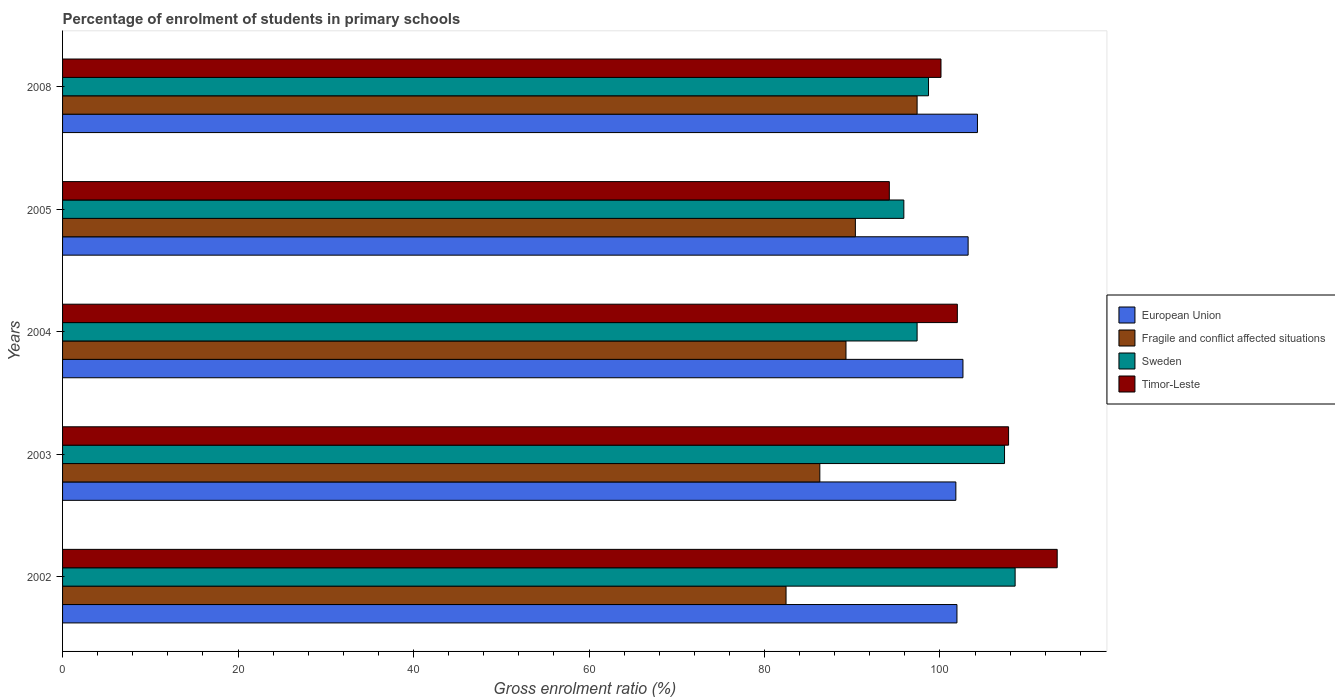How many different coloured bars are there?
Ensure brevity in your answer.  4. Are the number of bars per tick equal to the number of legend labels?
Give a very brief answer. Yes. Are the number of bars on each tick of the Y-axis equal?
Provide a short and direct response. Yes. How many bars are there on the 3rd tick from the top?
Make the answer very short. 4. How many bars are there on the 5th tick from the bottom?
Keep it short and to the point. 4. What is the label of the 2nd group of bars from the top?
Keep it short and to the point. 2005. In how many cases, is the number of bars for a given year not equal to the number of legend labels?
Your response must be concise. 0. What is the percentage of students enrolled in primary schools in Timor-Leste in 2003?
Your answer should be very brief. 107.82. Across all years, what is the maximum percentage of students enrolled in primary schools in European Union?
Provide a succinct answer. 104.27. Across all years, what is the minimum percentage of students enrolled in primary schools in Sweden?
Keep it short and to the point. 95.88. In which year was the percentage of students enrolled in primary schools in Timor-Leste maximum?
Keep it short and to the point. 2002. What is the total percentage of students enrolled in primary schools in Sweden in the graph?
Your answer should be compact. 507.89. What is the difference between the percentage of students enrolled in primary schools in European Union in 2005 and that in 2008?
Your response must be concise. -1.06. What is the difference between the percentage of students enrolled in primary schools in European Union in 2008 and the percentage of students enrolled in primary schools in Fragile and conflict affected situations in 2003?
Your answer should be very brief. 17.97. What is the average percentage of students enrolled in primary schools in Sweden per year?
Your answer should be very brief. 101.58. In the year 2002, what is the difference between the percentage of students enrolled in primary schools in Timor-Leste and percentage of students enrolled in primary schools in European Union?
Your answer should be very brief. 11.43. What is the ratio of the percentage of students enrolled in primary schools in Timor-Leste in 2003 to that in 2005?
Keep it short and to the point. 1.14. Is the percentage of students enrolled in primary schools in Sweden in 2005 less than that in 2008?
Provide a short and direct response. Yes. Is the difference between the percentage of students enrolled in primary schools in Timor-Leste in 2003 and 2004 greater than the difference between the percentage of students enrolled in primary schools in European Union in 2003 and 2004?
Offer a terse response. Yes. What is the difference between the highest and the second highest percentage of students enrolled in primary schools in Timor-Leste?
Offer a terse response. 5.54. What is the difference between the highest and the lowest percentage of students enrolled in primary schools in Timor-Leste?
Provide a succinct answer. 19.13. In how many years, is the percentage of students enrolled in primary schools in Timor-Leste greater than the average percentage of students enrolled in primary schools in Timor-Leste taken over all years?
Offer a terse response. 2. Is the sum of the percentage of students enrolled in primary schools in European Union in 2002 and 2008 greater than the maximum percentage of students enrolled in primary schools in Fragile and conflict affected situations across all years?
Provide a short and direct response. Yes. What does the 4th bar from the top in 2008 represents?
Keep it short and to the point. European Union. Is it the case that in every year, the sum of the percentage of students enrolled in primary schools in Timor-Leste and percentage of students enrolled in primary schools in Sweden is greater than the percentage of students enrolled in primary schools in European Union?
Give a very brief answer. Yes. How many years are there in the graph?
Ensure brevity in your answer.  5. Are the values on the major ticks of X-axis written in scientific E-notation?
Your response must be concise. No. Does the graph contain any zero values?
Offer a terse response. No. Does the graph contain grids?
Give a very brief answer. No. What is the title of the graph?
Provide a short and direct response. Percentage of enrolment of students in primary schools. Does "Turkey" appear as one of the legend labels in the graph?
Your response must be concise. No. What is the label or title of the X-axis?
Your answer should be compact. Gross enrolment ratio (%). What is the label or title of the Y-axis?
Give a very brief answer. Years. What is the Gross enrolment ratio (%) of European Union in 2002?
Your response must be concise. 101.93. What is the Gross enrolment ratio (%) in Fragile and conflict affected situations in 2002?
Provide a short and direct response. 82.46. What is the Gross enrolment ratio (%) of Sweden in 2002?
Offer a very short reply. 108.56. What is the Gross enrolment ratio (%) of Timor-Leste in 2002?
Ensure brevity in your answer.  113.36. What is the Gross enrolment ratio (%) of European Union in 2003?
Provide a succinct answer. 101.81. What is the Gross enrolment ratio (%) in Fragile and conflict affected situations in 2003?
Your response must be concise. 86.31. What is the Gross enrolment ratio (%) in Sweden in 2003?
Make the answer very short. 107.36. What is the Gross enrolment ratio (%) of Timor-Leste in 2003?
Provide a succinct answer. 107.82. What is the Gross enrolment ratio (%) in European Union in 2004?
Your answer should be very brief. 102.62. What is the Gross enrolment ratio (%) in Fragile and conflict affected situations in 2004?
Ensure brevity in your answer.  89.29. What is the Gross enrolment ratio (%) of Sweden in 2004?
Provide a short and direct response. 97.39. What is the Gross enrolment ratio (%) in Timor-Leste in 2004?
Your answer should be compact. 101.98. What is the Gross enrolment ratio (%) of European Union in 2005?
Your answer should be very brief. 103.21. What is the Gross enrolment ratio (%) in Fragile and conflict affected situations in 2005?
Offer a very short reply. 90.36. What is the Gross enrolment ratio (%) in Sweden in 2005?
Make the answer very short. 95.88. What is the Gross enrolment ratio (%) of Timor-Leste in 2005?
Provide a succinct answer. 94.23. What is the Gross enrolment ratio (%) in European Union in 2008?
Provide a succinct answer. 104.27. What is the Gross enrolment ratio (%) in Fragile and conflict affected situations in 2008?
Keep it short and to the point. 97.39. What is the Gross enrolment ratio (%) of Sweden in 2008?
Provide a succinct answer. 98.69. What is the Gross enrolment ratio (%) in Timor-Leste in 2008?
Provide a short and direct response. 100.11. Across all years, what is the maximum Gross enrolment ratio (%) in European Union?
Provide a succinct answer. 104.27. Across all years, what is the maximum Gross enrolment ratio (%) in Fragile and conflict affected situations?
Your answer should be very brief. 97.39. Across all years, what is the maximum Gross enrolment ratio (%) in Sweden?
Offer a terse response. 108.56. Across all years, what is the maximum Gross enrolment ratio (%) in Timor-Leste?
Keep it short and to the point. 113.36. Across all years, what is the minimum Gross enrolment ratio (%) in European Union?
Offer a terse response. 101.81. Across all years, what is the minimum Gross enrolment ratio (%) in Fragile and conflict affected situations?
Offer a terse response. 82.46. Across all years, what is the minimum Gross enrolment ratio (%) in Sweden?
Your answer should be very brief. 95.88. Across all years, what is the minimum Gross enrolment ratio (%) in Timor-Leste?
Provide a short and direct response. 94.23. What is the total Gross enrolment ratio (%) in European Union in the graph?
Your answer should be very brief. 513.84. What is the total Gross enrolment ratio (%) in Fragile and conflict affected situations in the graph?
Offer a very short reply. 445.8. What is the total Gross enrolment ratio (%) of Sweden in the graph?
Ensure brevity in your answer.  507.89. What is the total Gross enrolment ratio (%) of Timor-Leste in the graph?
Offer a very short reply. 517.5. What is the difference between the Gross enrolment ratio (%) in European Union in 2002 and that in 2003?
Your answer should be very brief. 0.12. What is the difference between the Gross enrolment ratio (%) of Fragile and conflict affected situations in 2002 and that in 2003?
Provide a short and direct response. -3.85. What is the difference between the Gross enrolment ratio (%) in Sweden in 2002 and that in 2003?
Keep it short and to the point. 1.21. What is the difference between the Gross enrolment ratio (%) of Timor-Leste in 2002 and that in 2003?
Ensure brevity in your answer.  5.54. What is the difference between the Gross enrolment ratio (%) in European Union in 2002 and that in 2004?
Make the answer very short. -0.68. What is the difference between the Gross enrolment ratio (%) in Fragile and conflict affected situations in 2002 and that in 2004?
Your answer should be compact. -6.83. What is the difference between the Gross enrolment ratio (%) in Sweden in 2002 and that in 2004?
Your answer should be compact. 11.17. What is the difference between the Gross enrolment ratio (%) of Timor-Leste in 2002 and that in 2004?
Ensure brevity in your answer.  11.38. What is the difference between the Gross enrolment ratio (%) in European Union in 2002 and that in 2005?
Make the answer very short. -1.27. What is the difference between the Gross enrolment ratio (%) of Fragile and conflict affected situations in 2002 and that in 2005?
Your response must be concise. -7.9. What is the difference between the Gross enrolment ratio (%) in Sweden in 2002 and that in 2005?
Your answer should be very brief. 12.68. What is the difference between the Gross enrolment ratio (%) of Timor-Leste in 2002 and that in 2005?
Ensure brevity in your answer.  19.13. What is the difference between the Gross enrolment ratio (%) in European Union in 2002 and that in 2008?
Give a very brief answer. -2.34. What is the difference between the Gross enrolment ratio (%) of Fragile and conflict affected situations in 2002 and that in 2008?
Provide a short and direct response. -14.94. What is the difference between the Gross enrolment ratio (%) in Sweden in 2002 and that in 2008?
Provide a short and direct response. 9.87. What is the difference between the Gross enrolment ratio (%) of Timor-Leste in 2002 and that in 2008?
Give a very brief answer. 13.24. What is the difference between the Gross enrolment ratio (%) in European Union in 2003 and that in 2004?
Your response must be concise. -0.81. What is the difference between the Gross enrolment ratio (%) in Fragile and conflict affected situations in 2003 and that in 2004?
Your answer should be compact. -2.98. What is the difference between the Gross enrolment ratio (%) of Sweden in 2003 and that in 2004?
Offer a very short reply. 9.96. What is the difference between the Gross enrolment ratio (%) in Timor-Leste in 2003 and that in 2004?
Provide a succinct answer. 5.84. What is the difference between the Gross enrolment ratio (%) in European Union in 2003 and that in 2005?
Give a very brief answer. -1.4. What is the difference between the Gross enrolment ratio (%) of Fragile and conflict affected situations in 2003 and that in 2005?
Make the answer very short. -4.05. What is the difference between the Gross enrolment ratio (%) in Sweden in 2003 and that in 2005?
Your answer should be very brief. 11.47. What is the difference between the Gross enrolment ratio (%) of Timor-Leste in 2003 and that in 2005?
Ensure brevity in your answer.  13.59. What is the difference between the Gross enrolment ratio (%) in European Union in 2003 and that in 2008?
Make the answer very short. -2.46. What is the difference between the Gross enrolment ratio (%) of Fragile and conflict affected situations in 2003 and that in 2008?
Provide a short and direct response. -11.09. What is the difference between the Gross enrolment ratio (%) of Sweden in 2003 and that in 2008?
Make the answer very short. 8.66. What is the difference between the Gross enrolment ratio (%) in Timor-Leste in 2003 and that in 2008?
Ensure brevity in your answer.  7.7. What is the difference between the Gross enrolment ratio (%) of European Union in 2004 and that in 2005?
Your answer should be compact. -0.59. What is the difference between the Gross enrolment ratio (%) of Fragile and conflict affected situations in 2004 and that in 2005?
Your answer should be very brief. -1.07. What is the difference between the Gross enrolment ratio (%) of Sweden in 2004 and that in 2005?
Your response must be concise. 1.51. What is the difference between the Gross enrolment ratio (%) in Timor-Leste in 2004 and that in 2005?
Provide a succinct answer. 7.75. What is the difference between the Gross enrolment ratio (%) of European Union in 2004 and that in 2008?
Offer a terse response. -1.65. What is the difference between the Gross enrolment ratio (%) in Fragile and conflict affected situations in 2004 and that in 2008?
Your answer should be compact. -8.11. What is the difference between the Gross enrolment ratio (%) of Sweden in 2004 and that in 2008?
Give a very brief answer. -1.3. What is the difference between the Gross enrolment ratio (%) of Timor-Leste in 2004 and that in 2008?
Offer a very short reply. 1.86. What is the difference between the Gross enrolment ratio (%) in European Union in 2005 and that in 2008?
Give a very brief answer. -1.06. What is the difference between the Gross enrolment ratio (%) in Fragile and conflict affected situations in 2005 and that in 2008?
Keep it short and to the point. -7.04. What is the difference between the Gross enrolment ratio (%) in Sweden in 2005 and that in 2008?
Keep it short and to the point. -2.81. What is the difference between the Gross enrolment ratio (%) of Timor-Leste in 2005 and that in 2008?
Provide a succinct answer. -5.89. What is the difference between the Gross enrolment ratio (%) of European Union in 2002 and the Gross enrolment ratio (%) of Fragile and conflict affected situations in 2003?
Make the answer very short. 15.63. What is the difference between the Gross enrolment ratio (%) in European Union in 2002 and the Gross enrolment ratio (%) in Sweden in 2003?
Your answer should be very brief. -5.42. What is the difference between the Gross enrolment ratio (%) of European Union in 2002 and the Gross enrolment ratio (%) of Timor-Leste in 2003?
Offer a terse response. -5.88. What is the difference between the Gross enrolment ratio (%) of Fragile and conflict affected situations in 2002 and the Gross enrolment ratio (%) of Sweden in 2003?
Provide a short and direct response. -24.9. What is the difference between the Gross enrolment ratio (%) of Fragile and conflict affected situations in 2002 and the Gross enrolment ratio (%) of Timor-Leste in 2003?
Your answer should be very brief. -25.36. What is the difference between the Gross enrolment ratio (%) of Sweden in 2002 and the Gross enrolment ratio (%) of Timor-Leste in 2003?
Make the answer very short. 0.75. What is the difference between the Gross enrolment ratio (%) in European Union in 2002 and the Gross enrolment ratio (%) in Fragile and conflict affected situations in 2004?
Provide a succinct answer. 12.65. What is the difference between the Gross enrolment ratio (%) in European Union in 2002 and the Gross enrolment ratio (%) in Sweden in 2004?
Give a very brief answer. 4.54. What is the difference between the Gross enrolment ratio (%) in European Union in 2002 and the Gross enrolment ratio (%) in Timor-Leste in 2004?
Provide a succinct answer. -0.05. What is the difference between the Gross enrolment ratio (%) in Fragile and conflict affected situations in 2002 and the Gross enrolment ratio (%) in Sweden in 2004?
Ensure brevity in your answer.  -14.94. What is the difference between the Gross enrolment ratio (%) of Fragile and conflict affected situations in 2002 and the Gross enrolment ratio (%) of Timor-Leste in 2004?
Your response must be concise. -19.52. What is the difference between the Gross enrolment ratio (%) in Sweden in 2002 and the Gross enrolment ratio (%) in Timor-Leste in 2004?
Provide a succinct answer. 6.59. What is the difference between the Gross enrolment ratio (%) in European Union in 2002 and the Gross enrolment ratio (%) in Fragile and conflict affected situations in 2005?
Your response must be concise. 11.58. What is the difference between the Gross enrolment ratio (%) in European Union in 2002 and the Gross enrolment ratio (%) in Sweden in 2005?
Offer a very short reply. 6.05. What is the difference between the Gross enrolment ratio (%) in European Union in 2002 and the Gross enrolment ratio (%) in Timor-Leste in 2005?
Give a very brief answer. 7.71. What is the difference between the Gross enrolment ratio (%) of Fragile and conflict affected situations in 2002 and the Gross enrolment ratio (%) of Sweden in 2005?
Make the answer very short. -13.43. What is the difference between the Gross enrolment ratio (%) in Fragile and conflict affected situations in 2002 and the Gross enrolment ratio (%) in Timor-Leste in 2005?
Give a very brief answer. -11.77. What is the difference between the Gross enrolment ratio (%) in Sweden in 2002 and the Gross enrolment ratio (%) in Timor-Leste in 2005?
Keep it short and to the point. 14.34. What is the difference between the Gross enrolment ratio (%) in European Union in 2002 and the Gross enrolment ratio (%) in Fragile and conflict affected situations in 2008?
Make the answer very short. 4.54. What is the difference between the Gross enrolment ratio (%) of European Union in 2002 and the Gross enrolment ratio (%) of Sweden in 2008?
Offer a very short reply. 3.24. What is the difference between the Gross enrolment ratio (%) of European Union in 2002 and the Gross enrolment ratio (%) of Timor-Leste in 2008?
Keep it short and to the point. 1.82. What is the difference between the Gross enrolment ratio (%) of Fragile and conflict affected situations in 2002 and the Gross enrolment ratio (%) of Sweden in 2008?
Provide a short and direct response. -16.24. What is the difference between the Gross enrolment ratio (%) in Fragile and conflict affected situations in 2002 and the Gross enrolment ratio (%) in Timor-Leste in 2008?
Your response must be concise. -17.66. What is the difference between the Gross enrolment ratio (%) of Sweden in 2002 and the Gross enrolment ratio (%) of Timor-Leste in 2008?
Ensure brevity in your answer.  8.45. What is the difference between the Gross enrolment ratio (%) in European Union in 2003 and the Gross enrolment ratio (%) in Fragile and conflict affected situations in 2004?
Your answer should be very brief. 12.52. What is the difference between the Gross enrolment ratio (%) of European Union in 2003 and the Gross enrolment ratio (%) of Sweden in 2004?
Keep it short and to the point. 4.42. What is the difference between the Gross enrolment ratio (%) in European Union in 2003 and the Gross enrolment ratio (%) in Timor-Leste in 2004?
Provide a succinct answer. -0.17. What is the difference between the Gross enrolment ratio (%) in Fragile and conflict affected situations in 2003 and the Gross enrolment ratio (%) in Sweden in 2004?
Offer a very short reply. -11.09. What is the difference between the Gross enrolment ratio (%) in Fragile and conflict affected situations in 2003 and the Gross enrolment ratio (%) in Timor-Leste in 2004?
Offer a terse response. -15.67. What is the difference between the Gross enrolment ratio (%) in Sweden in 2003 and the Gross enrolment ratio (%) in Timor-Leste in 2004?
Your answer should be very brief. 5.38. What is the difference between the Gross enrolment ratio (%) in European Union in 2003 and the Gross enrolment ratio (%) in Fragile and conflict affected situations in 2005?
Offer a very short reply. 11.45. What is the difference between the Gross enrolment ratio (%) in European Union in 2003 and the Gross enrolment ratio (%) in Sweden in 2005?
Make the answer very short. 5.93. What is the difference between the Gross enrolment ratio (%) of European Union in 2003 and the Gross enrolment ratio (%) of Timor-Leste in 2005?
Offer a terse response. 7.58. What is the difference between the Gross enrolment ratio (%) of Fragile and conflict affected situations in 2003 and the Gross enrolment ratio (%) of Sweden in 2005?
Give a very brief answer. -9.58. What is the difference between the Gross enrolment ratio (%) of Fragile and conflict affected situations in 2003 and the Gross enrolment ratio (%) of Timor-Leste in 2005?
Your response must be concise. -7.92. What is the difference between the Gross enrolment ratio (%) in Sweden in 2003 and the Gross enrolment ratio (%) in Timor-Leste in 2005?
Your answer should be compact. 13.13. What is the difference between the Gross enrolment ratio (%) of European Union in 2003 and the Gross enrolment ratio (%) of Fragile and conflict affected situations in 2008?
Offer a terse response. 4.42. What is the difference between the Gross enrolment ratio (%) of European Union in 2003 and the Gross enrolment ratio (%) of Sweden in 2008?
Your answer should be very brief. 3.12. What is the difference between the Gross enrolment ratio (%) in European Union in 2003 and the Gross enrolment ratio (%) in Timor-Leste in 2008?
Provide a succinct answer. 1.69. What is the difference between the Gross enrolment ratio (%) in Fragile and conflict affected situations in 2003 and the Gross enrolment ratio (%) in Sweden in 2008?
Keep it short and to the point. -12.39. What is the difference between the Gross enrolment ratio (%) of Fragile and conflict affected situations in 2003 and the Gross enrolment ratio (%) of Timor-Leste in 2008?
Keep it short and to the point. -13.81. What is the difference between the Gross enrolment ratio (%) of Sweden in 2003 and the Gross enrolment ratio (%) of Timor-Leste in 2008?
Offer a very short reply. 7.24. What is the difference between the Gross enrolment ratio (%) of European Union in 2004 and the Gross enrolment ratio (%) of Fragile and conflict affected situations in 2005?
Ensure brevity in your answer.  12.26. What is the difference between the Gross enrolment ratio (%) in European Union in 2004 and the Gross enrolment ratio (%) in Sweden in 2005?
Offer a terse response. 6.74. What is the difference between the Gross enrolment ratio (%) in European Union in 2004 and the Gross enrolment ratio (%) in Timor-Leste in 2005?
Give a very brief answer. 8.39. What is the difference between the Gross enrolment ratio (%) of Fragile and conflict affected situations in 2004 and the Gross enrolment ratio (%) of Sweden in 2005?
Offer a terse response. -6.59. What is the difference between the Gross enrolment ratio (%) of Fragile and conflict affected situations in 2004 and the Gross enrolment ratio (%) of Timor-Leste in 2005?
Make the answer very short. -4.94. What is the difference between the Gross enrolment ratio (%) of Sweden in 2004 and the Gross enrolment ratio (%) of Timor-Leste in 2005?
Your answer should be compact. 3.17. What is the difference between the Gross enrolment ratio (%) of European Union in 2004 and the Gross enrolment ratio (%) of Fragile and conflict affected situations in 2008?
Offer a very short reply. 5.22. What is the difference between the Gross enrolment ratio (%) in European Union in 2004 and the Gross enrolment ratio (%) in Sweden in 2008?
Give a very brief answer. 3.92. What is the difference between the Gross enrolment ratio (%) in European Union in 2004 and the Gross enrolment ratio (%) in Timor-Leste in 2008?
Offer a very short reply. 2.5. What is the difference between the Gross enrolment ratio (%) of Fragile and conflict affected situations in 2004 and the Gross enrolment ratio (%) of Sweden in 2008?
Offer a terse response. -9.41. What is the difference between the Gross enrolment ratio (%) in Fragile and conflict affected situations in 2004 and the Gross enrolment ratio (%) in Timor-Leste in 2008?
Make the answer very short. -10.83. What is the difference between the Gross enrolment ratio (%) of Sweden in 2004 and the Gross enrolment ratio (%) of Timor-Leste in 2008?
Your answer should be compact. -2.72. What is the difference between the Gross enrolment ratio (%) in European Union in 2005 and the Gross enrolment ratio (%) in Fragile and conflict affected situations in 2008?
Your response must be concise. 5.81. What is the difference between the Gross enrolment ratio (%) in European Union in 2005 and the Gross enrolment ratio (%) in Sweden in 2008?
Keep it short and to the point. 4.51. What is the difference between the Gross enrolment ratio (%) in European Union in 2005 and the Gross enrolment ratio (%) in Timor-Leste in 2008?
Give a very brief answer. 3.09. What is the difference between the Gross enrolment ratio (%) in Fragile and conflict affected situations in 2005 and the Gross enrolment ratio (%) in Sweden in 2008?
Make the answer very short. -8.34. What is the difference between the Gross enrolment ratio (%) of Fragile and conflict affected situations in 2005 and the Gross enrolment ratio (%) of Timor-Leste in 2008?
Ensure brevity in your answer.  -9.76. What is the difference between the Gross enrolment ratio (%) of Sweden in 2005 and the Gross enrolment ratio (%) of Timor-Leste in 2008?
Give a very brief answer. -4.23. What is the average Gross enrolment ratio (%) of European Union per year?
Offer a very short reply. 102.77. What is the average Gross enrolment ratio (%) in Fragile and conflict affected situations per year?
Your answer should be compact. 89.16. What is the average Gross enrolment ratio (%) of Sweden per year?
Give a very brief answer. 101.58. What is the average Gross enrolment ratio (%) of Timor-Leste per year?
Your response must be concise. 103.5. In the year 2002, what is the difference between the Gross enrolment ratio (%) of European Union and Gross enrolment ratio (%) of Fragile and conflict affected situations?
Provide a succinct answer. 19.48. In the year 2002, what is the difference between the Gross enrolment ratio (%) in European Union and Gross enrolment ratio (%) in Sweden?
Offer a very short reply. -6.63. In the year 2002, what is the difference between the Gross enrolment ratio (%) of European Union and Gross enrolment ratio (%) of Timor-Leste?
Your answer should be very brief. -11.43. In the year 2002, what is the difference between the Gross enrolment ratio (%) of Fragile and conflict affected situations and Gross enrolment ratio (%) of Sweden?
Offer a terse response. -26.11. In the year 2002, what is the difference between the Gross enrolment ratio (%) in Fragile and conflict affected situations and Gross enrolment ratio (%) in Timor-Leste?
Provide a succinct answer. -30.9. In the year 2002, what is the difference between the Gross enrolment ratio (%) in Sweden and Gross enrolment ratio (%) in Timor-Leste?
Provide a succinct answer. -4.79. In the year 2003, what is the difference between the Gross enrolment ratio (%) in European Union and Gross enrolment ratio (%) in Fragile and conflict affected situations?
Your answer should be compact. 15.5. In the year 2003, what is the difference between the Gross enrolment ratio (%) in European Union and Gross enrolment ratio (%) in Sweden?
Give a very brief answer. -5.55. In the year 2003, what is the difference between the Gross enrolment ratio (%) of European Union and Gross enrolment ratio (%) of Timor-Leste?
Keep it short and to the point. -6.01. In the year 2003, what is the difference between the Gross enrolment ratio (%) in Fragile and conflict affected situations and Gross enrolment ratio (%) in Sweden?
Provide a succinct answer. -21.05. In the year 2003, what is the difference between the Gross enrolment ratio (%) in Fragile and conflict affected situations and Gross enrolment ratio (%) in Timor-Leste?
Give a very brief answer. -21.51. In the year 2003, what is the difference between the Gross enrolment ratio (%) in Sweden and Gross enrolment ratio (%) in Timor-Leste?
Provide a succinct answer. -0.46. In the year 2004, what is the difference between the Gross enrolment ratio (%) of European Union and Gross enrolment ratio (%) of Fragile and conflict affected situations?
Your answer should be compact. 13.33. In the year 2004, what is the difference between the Gross enrolment ratio (%) of European Union and Gross enrolment ratio (%) of Sweden?
Make the answer very short. 5.23. In the year 2004, what is the difference between the Gross enrolment ratio (%) of European Union and Gross enrolment ratio (%) of Timor-Leste?
Make the answer very short. 0.64. In the year 2004, what is the difference between the Gross enrolment ratio (%) in Fragile and conflict affected situations and Gross enrolment ratio (%) in Sweden?
Offer a very short reply. -8.11. In the year 2004, what is the difference between the Gross enrolment ratio (%) of Fragile and conflict affected situations and Gross enrolment ratio (%) of Timor-Leste?
Provide a short and direct response. -12.69. In the year 2004, what is the difference between the Gross enrolment ratio (%) of Sweden and Gross enrolment ratio (%) of Timor-Leste?
Offer a very short reply. -4.59. In the year 2005, what is the difference between the Gross enrolment ratio (%) in European Union and Gross enrolment ratio (%) in Fragile and conflict affected situations?
Your response must be concise. 12.85. In the year 2005, what is the difference between the Gross enrolment ratio (%) in European Union and Gross enrolment ratio (%) in Sweden?
Keep it short and to the point. 7.33. In the year 2005, what is the difference between the Gross enrolment ratio (%) in European Union and Gross enrolment ratio (%) in Timor-Leste?
Provide a succinct answer. 8.98. In the year 2005, what is the difference between the Gross enrolment ratio (%) in Fragile and conflict affected situations and Gross enrolment ratio (%) in Sweden?
Ensure brevity in your answer.  -5.52. In the year 2005, what is the difference between the Gross enrolment ratio (%) of Fragile and conflict affected situations and Gross enrolment ratio (%) of Timor-Leste?
Provide a short and direct response. -3.87. In the year 2005, what is the difference between the Gross enrolment ratio (%) of Sweden and Gross enrolment ratio (%) of Timor-Leste?
Your answer should be very brief. 1.66. In the year 2008, what is the difference between the Gross enrolment ratio (%) of European Union and Gross enrolment ratio (%) of Fragile and conflict affected situations?
Provide a succinct answer. 6.88. In the year 2008, what is the difference between the Gross enrolment ratio (%) in European Union and Gross enrolment ratio (%) in Sweden?
Provide a short and direct response. 5.58. In the year 2008, what is the difference between the Gross enrolment ratio (%) in European Union and Gross enrolment ratio (%) in Timor-Leste?
Keep it short and to the point. 4.16. In the year 2008, what is the difference between the Gross enrolment ratio (%) in Fragile and conflict affected situations and Gross enrolment ratio (%) in Sweden?
Make the answer very short. -1.3. In the year 2008, what is the difference between the Gross enrolment ratio (%) in Fragile and conflict affected situations and Gross enrolment ratio (%) in Timor-Leste?
Offer a very short reply. -2.72. In the year 2008, what is the difference between the Gross enrolment ratio (%) of Sweden and Gross enrolment ratio (%) of Timor-Leste?
Offer a very short reply. -1.42. What is the ratio of the Gross enrolment ratio (%) of European Union in 2002 to that in 2003?
Your answer should be very brief. 1. What is the ratio of the Gross enrolment ratio (%) of Fragile and conflict affected situations in 2002 to that in 2003?
Provide a succinct answer. 0.96. What is the ratio of the Gross enrolment ratio (%) of Sweden in 2002 to that in 2003?
Your answer should be very brief. 1.01. What is the ratio of the Gross enrolment ratio (%) in Timor-Leste in 2002 to that in 2003?
Make the answer very short. 1.05. What is the ratio of the Gross enrolment ratio (%) in European Union in 2002 to that in 2004?
Your response must be concise. 0.99. What is the ratio of the Gross enrolment ratio (%) in Fragile and conflict affected situations in 2002 to that in 2004?
Offer a terse response. 0.92. What is the ratio of the Gross enrolment ratio (%) of Sweden in 2002 to that in 2004?
Provide a succinct answer. 1.11. What is the ratio of the Gross enrolment ratio (%) of Timor-Leste in 2002 to that in 2004?
Provide a short and direct response. 1.11. What is the ratio of the Gross enrolment ratio (%) of European Union in 2002 to that in 2005?
Offer a very short reply. 0.99. What is the ratio of the Gross enrolment ratio (%) of Fragile and conflict affected situations in 2002 to that in 2005?
Ensure brevity in your answer.  0.91. What is the ratio of the Gross enrolment ratio (%) of Sweden in 2002 to that in 2005?
Ensure brevity in your answer.  1.13. What is the ratio of the Gross enrolment ratio (%) in Timor-Leste in 2002 to that in 2005?
Make the answer very short. 1.2. What is the ratio of the Gross enrolment ratio (%) in European Union in 2002 to that in 2008?
Offer a terse response. 0.98. What is the ratio of the Gross enrolment ratio (%) of Fragile and conflict affected situations in 2002 to that in 2008?
Your answer should be very brief. 0.85. What is the ratio of the Gross enrolment ratio (%) of Timor-Leste in 2002 to that in 2008?
Make the answer very short. 1.13. What is the ratio of the Gross enrolment ratio (%) of European Union in 2003 to that in 2004?
Give a very brief answer. 0.99. What is the ratio of the Gross enrolment ratio (%) in Fragile and conflict affected situations in 2003 to that in 2004?
Provide a short and direct response. 0.97. What is the ratio of the Gross enrolment ratio (%) in Sweden in 2003 to that in 2004?
Ensure brevity in your answer.  1.1. What is the ratio of the Gross enrolment ratio (%) of Timor-Leste in 2003 to that in 2004?
Provide a succinct answer. 1.06. What is the ratio of the Gross enrolment ratio (%) in European Union in 2003 to that in 2005?
Ensure brevity in your answer.  0.99. What is the ratio of the Gross enrolment ratio (%) in Fragile and conflict affected situations in 2003 to that in 2005?
Your answer should be very brief. 0.96. What is the ratio of the Gross enrolment ratio (%) of Sweden in 2003 to that in 2005?
Offer a terse response. 1.12. What is the ratio of the Gross enrolment ratio (%) in Timor-Leste in 2003 to that in 2005?
Make the answer very short. 1.14. What is the ratio of the Gross enrolment ratio (%) in European Union in 2003 to that in 2008?
Ensure brevity in your answer.  0.98. What is the ratio of the Gross enrolment ratio (%) of Fragile and conflict affected situations in 2003 to that in 2008?
Provide a short and direct response. 0.89. What is the ratio of the Gross enrolment ratio (%) of Sweden in 2003 to that in 2008?
Your answer should be compact. 1.09. What is the ratio of the Gross enrolment ratio (%) in Timor-Leste in 2003 to that in 2008?
Your response must be concise. 1.08. What is the ratio of the Gross enrolment ratio (%) of Fragile and conflict affected situations in 2004 to that in 2005?
Ensure brevity in your answer.  0.99. What is the ratio of the Gross enrolment ratio (%) in Sweden in 2004 to that in 2005?
Offer a terse response. 1.02. What is the ratio of the Gross enrolment ratio (%) of Timor-Leste in 2004 to that in 2005?
Provide a succinct answer. 1.08. What is the ratio of the Gross enrolment ratio (%) in European Union in 2004 to that in 2008?
Your answer should be very brief. 0.98. What is the ratio of the Gross enrolment ratio (%) of Fragile and conflict affected situations in 2004 to that in 2008?
Provide a succinct answer. 0.92. What is the ratio of the Gross enrolment ratio (%) of Sweden in 2004 to that in 2008?
Make the answer very short. 0.99. What is the ratio of the Gross enrolment ratio (%) of Timor-Leste in 2004 to that in 2008?
Your answer should be very brief. 1.02. What is the ratio of the Gross enrolment ratio (%) in Fragile and conflict affected situations in 2005 to that in 2008?
Your answer should be very brief. 0.93. What is the ratio of the Gross enrolment ratio (%) of Sweden in 2005 to that in 2008?
Offer a very short reply. 0.97. What is the ratio of the Gross enrolment ratio (%) of Timor-Leste in 2005 to that in 2008?
Offer a very short reply. 0.94. What is the difference between the highest and the second highest Gross enrolment ratio (%) in European Union?
Offer a terse response. 1.06. What is the difference between the highest and the second highest Gross enrolment ratio (%) of Fragile and conflict affected situations?
Your answer should be compact. 7.04. What is the difference between the highest and the second highest Gross enrolment ratio (%) of Sweden?
Provide a short and direct response. 1.21. What is the difference between the highest and the second highest Gross enrolment ratio (%) in Timor-Leste?
Offer a terse response. 5.54. What is the difference between the highest and the lowest Gross enrolment ratio (%) of European Union?
Ensure brevity in your answer.  2.46. What is the difference between the highest and the lowest Gross enrolment ratio (%) in Fragile and conflict affected situations?
Ensure brevity in your answer.  14.94. What is the difference between the highest and the lowest Gross enrolment ratio (%) of Sweden?
Your answer should be compact. 12.68. What is the difference between the highest and the lowest Gross enrolment ratio (%) of Timor-Leste?
Your answer should be compact. 19.13. 